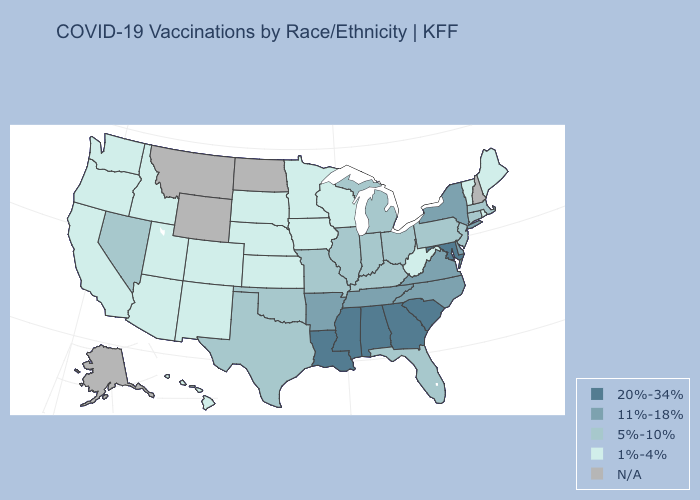What is the lowest value in the West?
Short answer required. 1%-4%. Which states have the highest value in the USA?
Concise answer only. Alabama, Georgia, Louisiana, Maryland, Mississippi, South Carolina. Name the states that have a value in the range N/A?
Quick response, please. Alaska, Montana, New Hampshire, North Dakota, Wyoming. What is the highest value in states that border Delaware?
Give a very brief answer. 20%-34%. What is the lowest value in the MidWest?
Write a very short answer. 1%-4%. What is the value of Kentucky?
Concise answer only. 5%-10%. What is the value of Maine?
Give a very brief answer. 1%-4%. What is the highest value in the West ?
Give a very brief answer. 5%-10%. Name the states that have a value in the range N/A?
Be succinct. Alaska, Montana, New Hampshire, North Dakota, Wyoming. What is the lowest value in the USA?
Be succinct. 1%-4%. Name the states that have a value in the range N/A?
Quick response, please. Alaska, Montana, New Hampshire, North Dakota, Wyoming. Does the map have missing data?
Give a very brief answer. Yes. Does Michigan have the highest value in the MidWest?
Concise answer only. Yes. Name the states that have a value in the range 20%-34%?
Concise answer only. Alabama, Georgia, Louisiana, Maryland, Mississippi, South Carolina. 